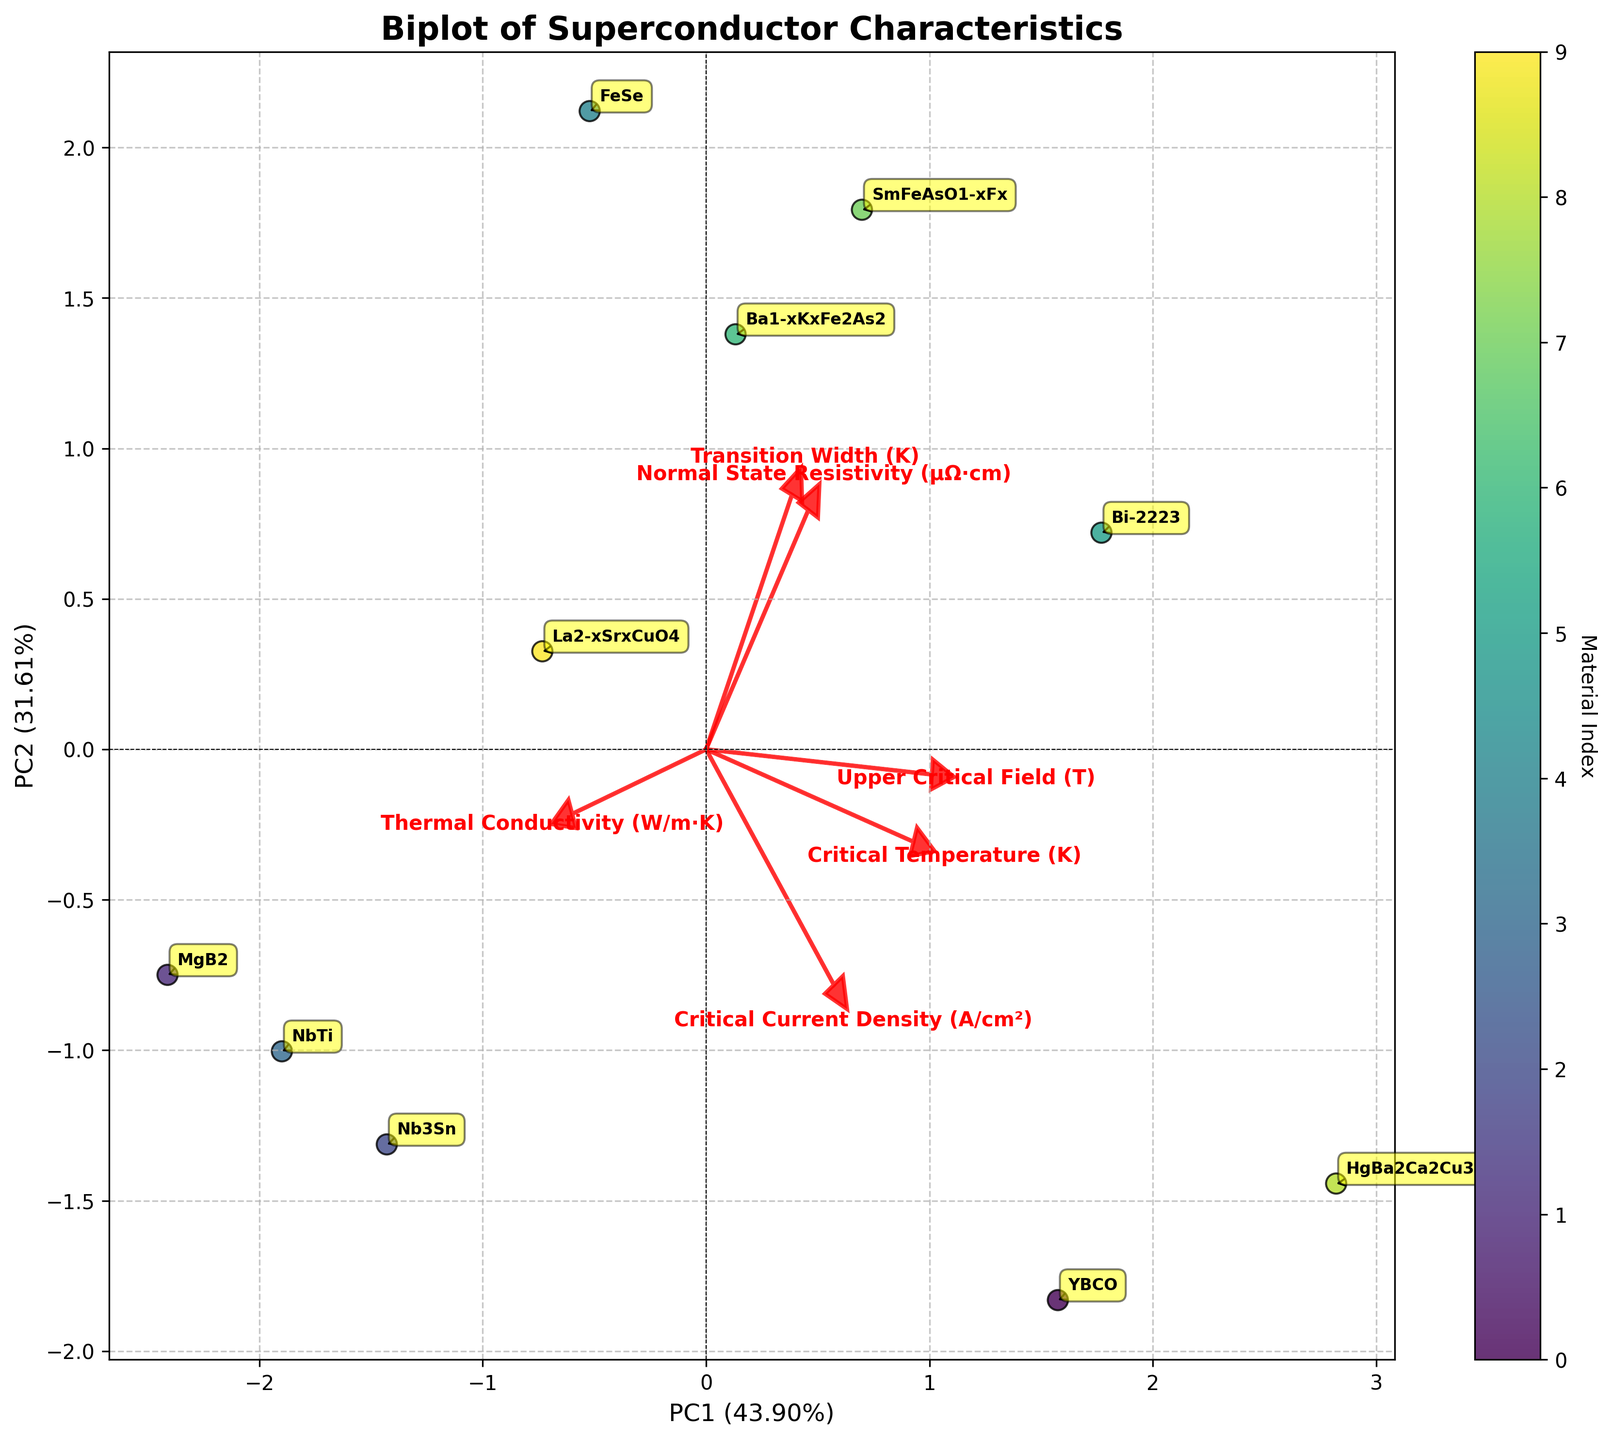What does the title of the plot say? The title is displayed prominently at the top of the plot. Reading it will give the specific subject of the biplot.
Answer: Biplot of Superconductor Characteristics How many principal components are shown in the plot? The x-axis and y-axis labels indicate the number of principal components in the plot because each axis corresponds to one principal component.
Answer: 2 Which material is represented by the point located furthest to the right on the plot? Locate the point on the rightmost side of the plot and look at the corresponding material annotation.
Answer: SmFeAsO1-xFx Which material has the highest Critical Temperature (K) in the plot? Critical Temperature (K) is one of the eigenvectors labeled in red, find the point furthest along this vector and read its corresponding annotation.
Answer: HgBa2Ca2Cu3O8+δ How does the Critical Temperature (K) vector relate to the Critical Current Density (A/cm²) vector? Examine the red arrow vectors representing these two quantities. Determine their relative direction and angle.
Answer: They are almost orthogonal Which two materials are most similar in terms of their positions on PC1 and PC2? Look for two points that are closest to each other in both x (PC1) and y (PC2) coordinates and read their labels.
Answer: Ba1-xKxFe2As2 and La2-xSrxCuO4 What does the arrow labeled "Thermal Conductivity (W/m·K)" indicate in the context of the principal components? The direction and length of this eigenvector indicate how much this feature contributes to the principal components.
Answer: Points with high values of PC2 tend to have higher Thermal Conductivity Which material has the highest value for Normal State Resistivity (μΩ·cm)? Identify the point furthest in the direction of the Normal State Resistivity eigenvector and read its corresponding material label.
Answer: FeSe Compare the values for Critical Temperature (K) and Upper Critical Field (T) for YBCO and MgB2. What can you conclude? Find the positions of YBCO and MgB2 along the PC1 and PC2 dimensions, particularly noting their projection on the eigenvectors. MgB2 is further along the Critical Temperature vector while YBCO along the Upper Critical Field eigenvector.
Answer: YBCO has a higher Upper Critical Field, and MgB2 has a lower Critical Temperature Which feature contributes the most to the first principal component (PC1)? Identify the arrow with the largest magnitude in the direction of PC1.
Answer: Critical Temperature (K) 